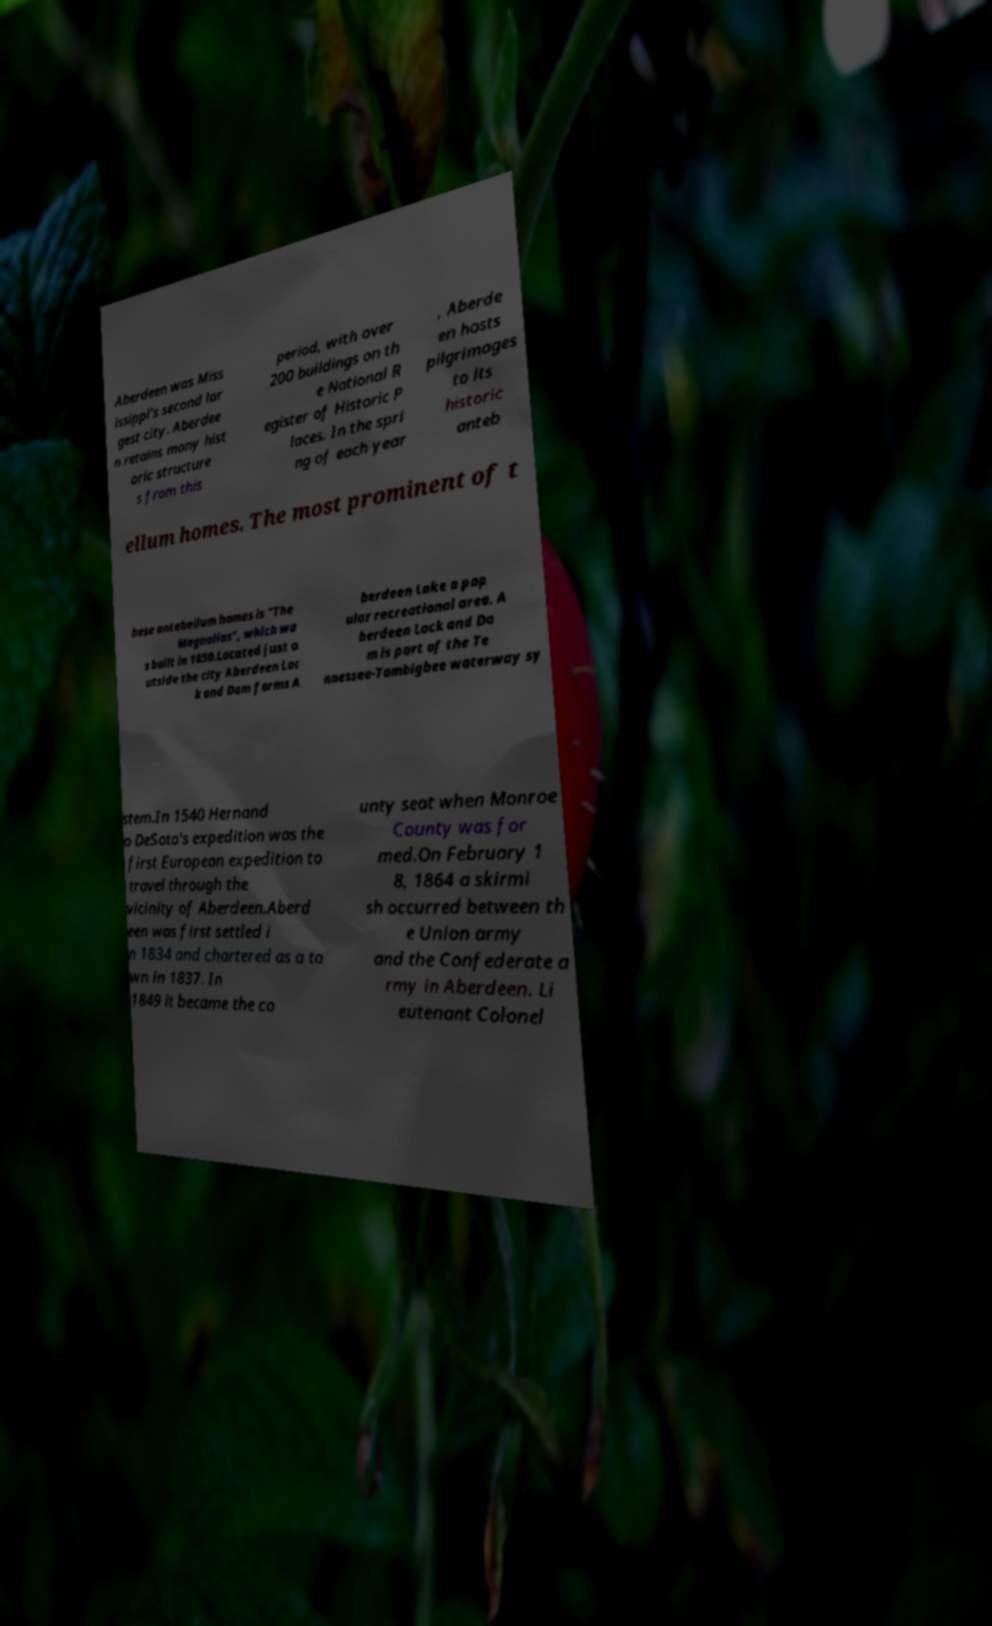I need the written content from this picture converted into text. Can you do that? Aberdeen was Miss issippi's second lar gest city. Aberdee n retains many hist oric structure s from this period, with over 200 buildings on th e National R egister of Historic P laces. In the spri ng of each year , Aberde en hosts pilgrimages to its historic anteb ellum homes. The most prominent of t hese antebellum homes is "The Magnolias", which wa s built in 1850.Located just o utside the city Aberdeen Loc k and Dam forms A berdeen Lake a pop ular recreational area. A berdeen Lock and Da m is part of the Te nnessee-Tombigbee waterway sy stem.In 1540 Hernand o DeSoto's expedition was the first European expedition to travel through the vicinity of Aberdeen.Aberd een was first settled i n 1834 and chartered as a to wn in 1837. In 1849 it became the co unty seat when Monroe County was for med.On February 1 8, 1864 a skirmi sh occurred between th e Union army and the Confederate a rmy in Aberdeen. Li eutenant Colonel 